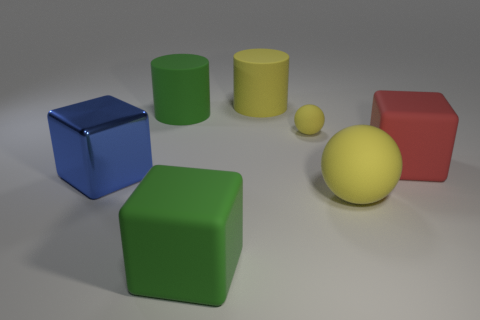Add 2 large metal blocks. How many objects exist? 9 Subtract all cubes. How many objects are left? 4 Subtract 0 brown blocks. How many objects are left? 7 Subtract all tiny spheres. Subtract all red matte things. How many objects are left? 5 Add 7 tiny things. How many tiny things are left? 8 Add 5 large shiny cubes. How many large shiny cubes exist? 6 